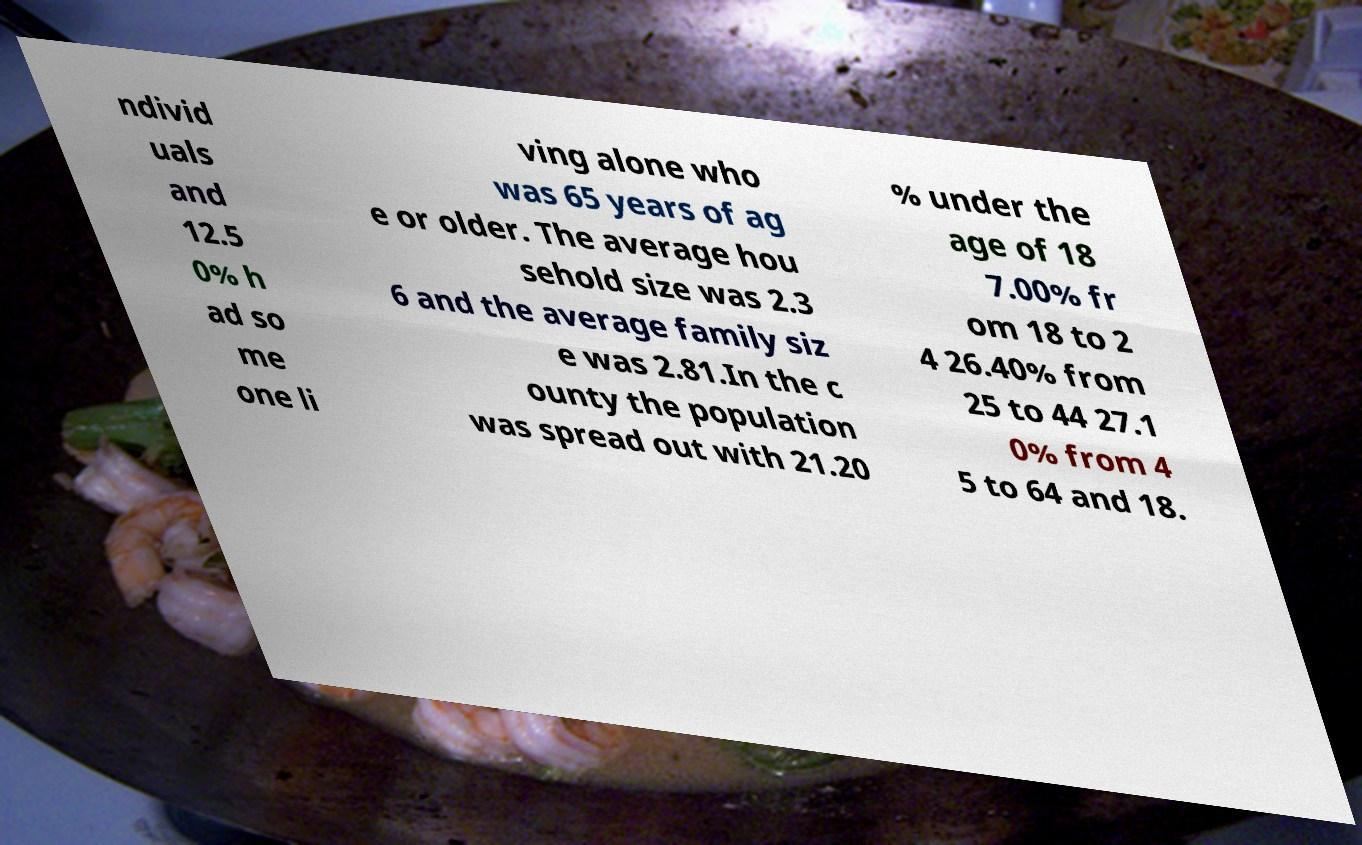Can you read and provide the text displayed in the image?This photo seems to have some interesting text. Can you extract and type it out for me? ndivid uals and 12.5 0% h ad so me one li ving alone who was 65 years of ag e or older. The average hou sehold size was 2.3 6 and the average family siz e was 2.81.In the c ounty the population was spread out with 21.20 % under the age of 18 7.00% fr om 18 to 2 4 26.40% from 25 to 44 27.1 0% from 4 5 to 64 and 18. 